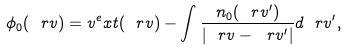Convert formula to latex. <formula><loc_0><loc_0><loc_500><loc_500>\phi _ { 0 } ( \ r v ) = v ^ { e } x t ( \ r v ) - \int \frac { n _ { 0 } ( \ r v ^ { \prime } ) } { | \ r v - \ r v ^ { \prime } | } d \ r v ^ { \prime } ,</formula> 